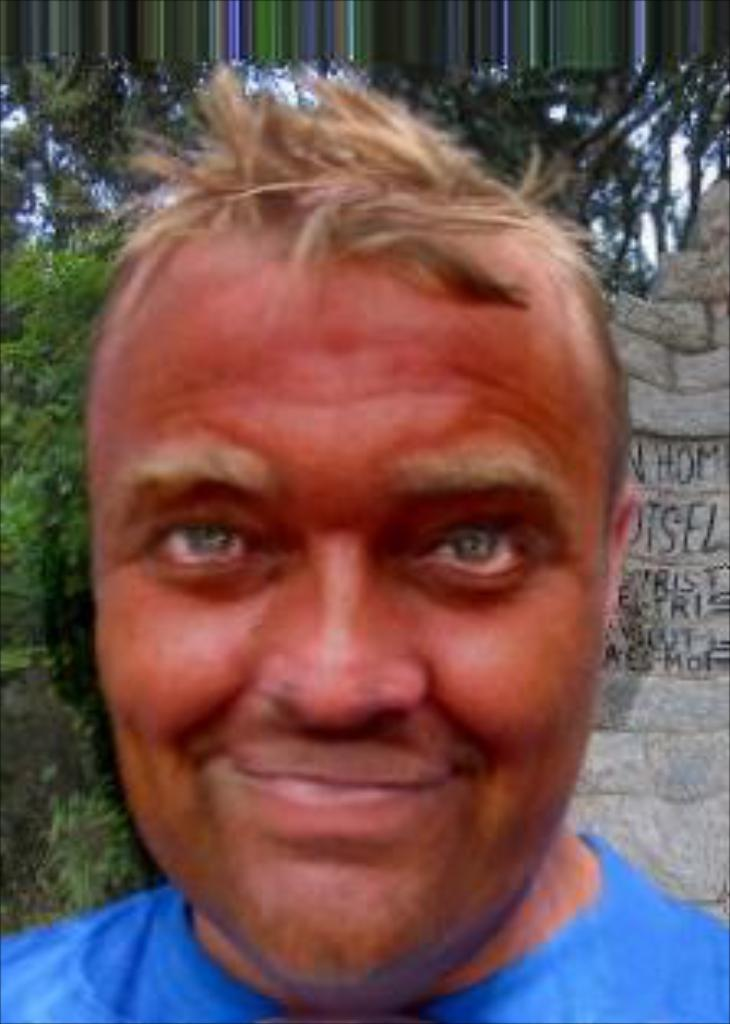Who is the main subject in the image? There is a man in the middle of the image. What is located behind the man? There are rocks and trees behind the man. What type of pollution can be seen in the image? There is no pollution visible in the image; it features a man with rocks and trees behind him. 